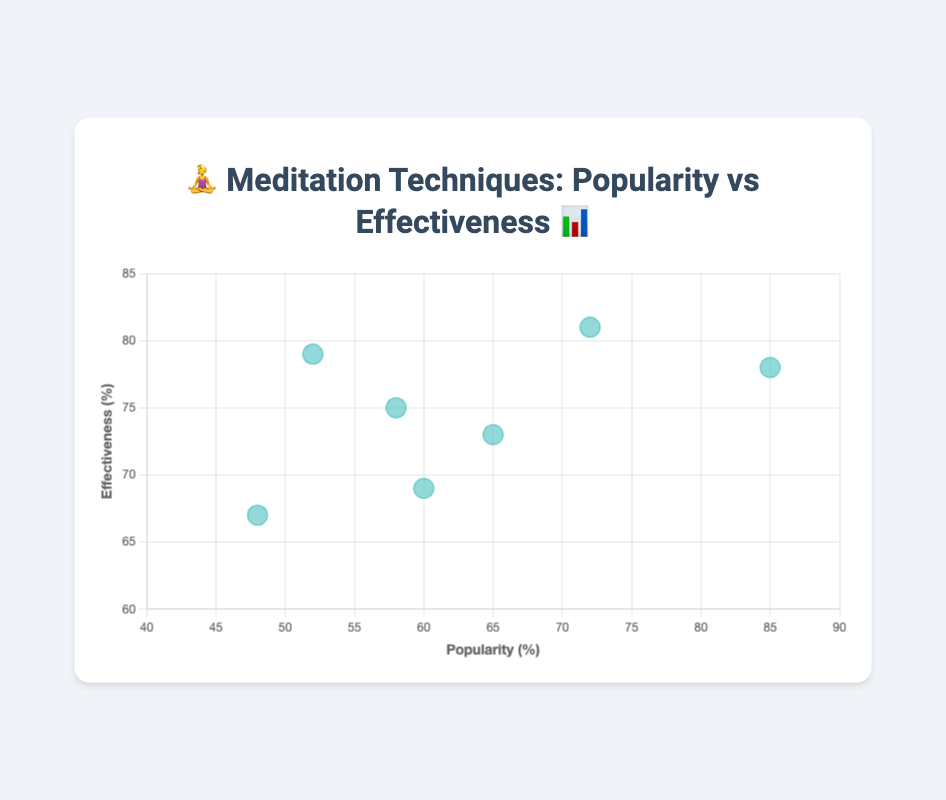What's the popularity of Zen Meditation ☯️? The chart shows bubbles with popularity on the x-axis, and you can find the Zen Meditation bubble marked with ☯️. It aligns with 58 on the x-axis.
Answer: 58 Which meditation technique is the most effective? Effectiveness is shown on the y-axis. The highest point on this axis belongs to Transcendental Meditation 🕉️, which aligns with 81%.
Answer: Transcendental Meditation How do Body Scan 🔍 and Chakra 🌈 Meditations compare in terms of effectiveness? Effectiveness is on the y-axis. Body Scan Meditation is at 69%, and Chakra Meditation is at 67%. Body Scan Meditation is slightly more effective.
Answer: Body Scan is more effective What's the average effectiveness of Mindfulness Meditation 🧘 and Loving-Kindness Meditation ❤️? Mindfulness Meditation effectiveness is 78%, Loving-Kindness Meditation is 73%. The average is (78 + 73) / 2 = 75.5%.
Answer: 75.5% Which meditation technique has the smallest bubble and what does it represent? All bubbles are of the same size in this chart, representing each meditation technique, not a data attribute.
Answer: All bubbles are same size What's the difference in popularity between the most and least popular techniques? The most popular is Mindfulness Meditation 🧘 at 85%, and the least popular is Chakra Meditation 🌈 at 48%. The difference is 85 - 48 = 37.
Answer: 37 How many techniques have an effectiveness greater than 75%? Check the y-axis for effectiveness. Mindfulness Meditation (78%), Transcendental Meditation (81%), Zen Meditation (75%), and Vipassana Meditation (79%) are all greater than 75%.
Answer: 4 